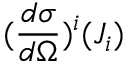Convert formula to latex. <formula><loc_0><loc_0><loc_500><loc_500>( \frac { d \sigma } { d \Omega } ) ^ { i } ( J _ { i } )</formula> 